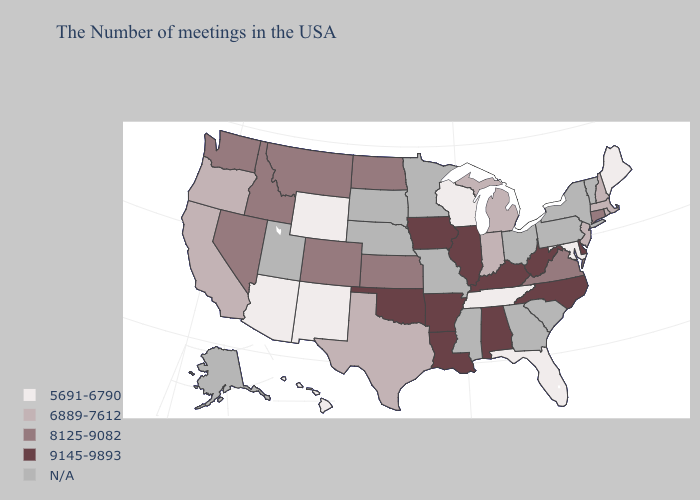Name the states that have a value in the range 5691-6790?
Quick response, please. Maine, Maryland, Florida, Tennessee, Wisconsin, Wyoming, New Mexico, Arizona, Hawaii. Which states have the lowest value in the USA?
Concise answer only. Maine, Maryland, Florida, Tennessee, Wisconsin, Wyoming, New Mexico, Arizona, Hawaii. Does Wisconsin have the lowest value in the MidWest?
Short answer required. Yes. Does Alabama have the highest value in the USA?
Be succinct. Yes. What is the value of Wisconsin?
Give a very brief answer. 5691-6790. Does Illinois have the highest value in the USA?
Be succinct. Yes. Which states have the highest value in the USA?
Write a very short answer. Delaware, North Carolina, West Virginia, Kentucky, Alabama, Illinois, Louisiana, Arkansas, Iowa, Oklahoma. Which states have the highest value in the USA?
Quick response, please. Delaware, North Carolina, West Virginia, Kentucky, Alabama, Illinois, Louisiana, Arkansas, Iowa, Oklahoma. What is the value of Alabama?
Be succinct. 9145-9893. What is the highest value in states that border Iowa?
Answer briefly. 9145-9893. What is the value of New Hampshire?
Quick response, please. 6889-7612. Does the map have missing data?
Quick response, please. Yes. 